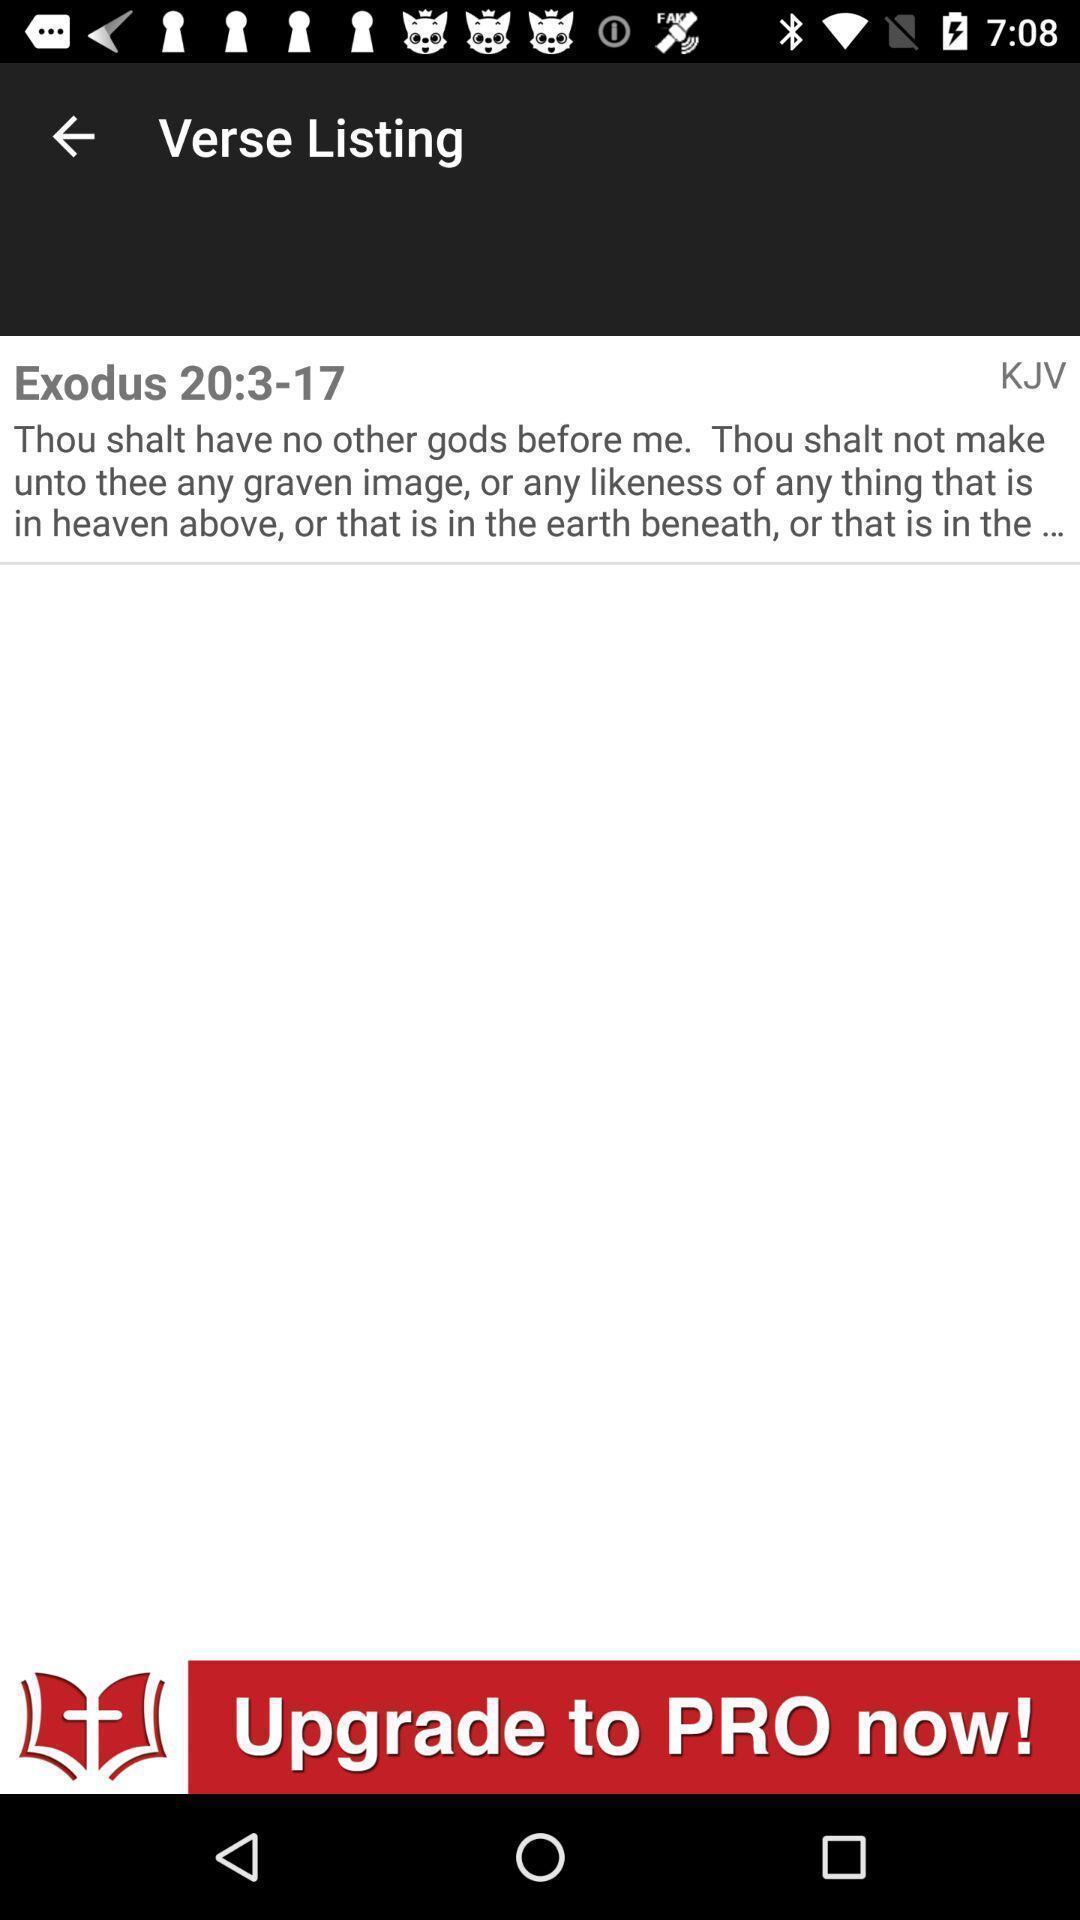Provide a textual representation of this image. Screen displaying information in listing page. 